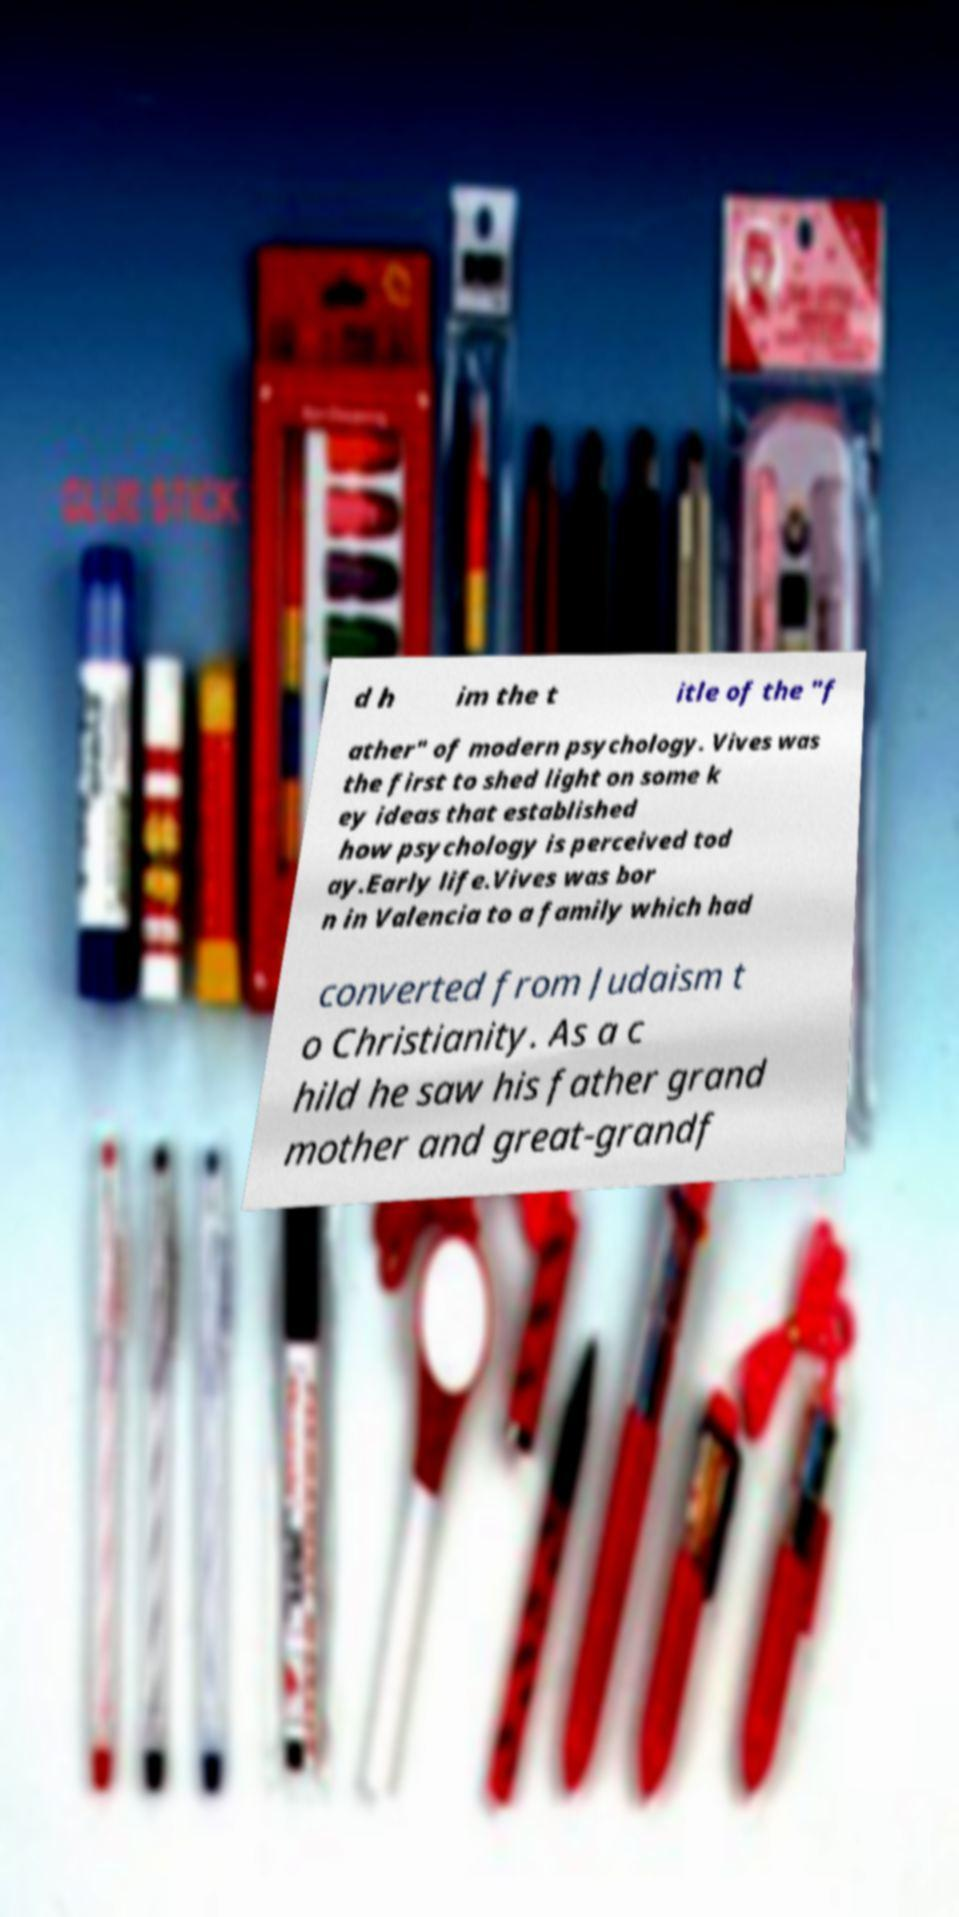I need the written content from this picture converted into text. Can you do that? d h im the t itle of the "f ather" of modern psychology. Vives was the first to shed light on some k ey ideas that established how psychology is perceived tod ay.Early life.Vives was bor n in Valencia to a family which had converted from Judaism t o Christianity. As a c hild he saw his father grand mother and great-grandf 